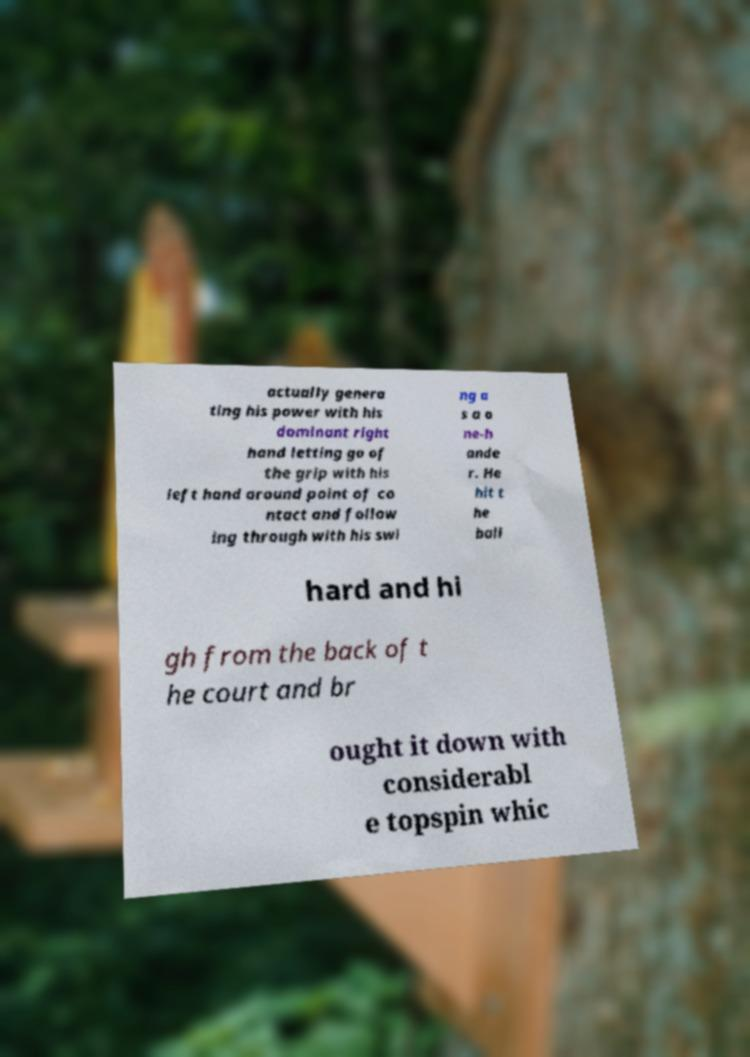There's text embedded in this image that I need extracted. Can you transcribe it verbatim? actually genera ting his power with his dominant right hand letting go of the grip with his left hand around point of co ntact and follow ing through with his swi ng a s a o ne-h ande r. He hit t he ball hard and hi gh from the back of t he court and br ought it down with considerabl e topspin whic 